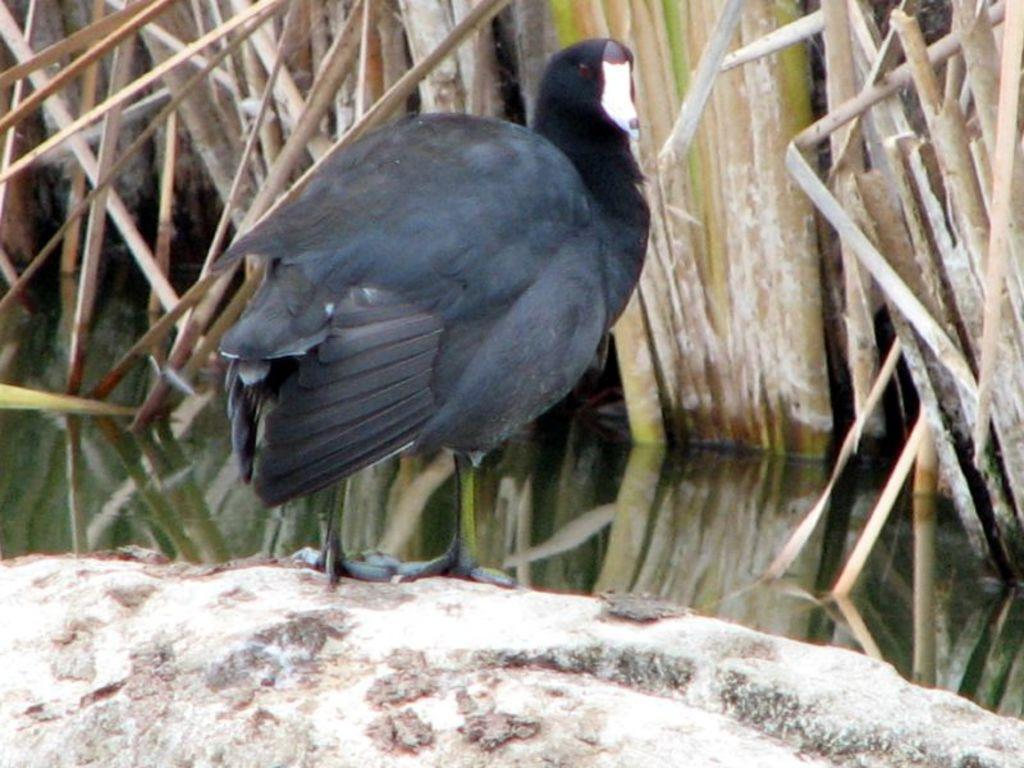What type of animal is in the image? There is a black bird in the image. Where is the bird located in the image? The bird is on an object. What natural elements can be seen in the image? Water and grass are visible in the image. What type of cream is being used to mark the bird's territory in the image? There is no cream or territory marking present in the image; it features a black bird on an object with water and grass visible. 